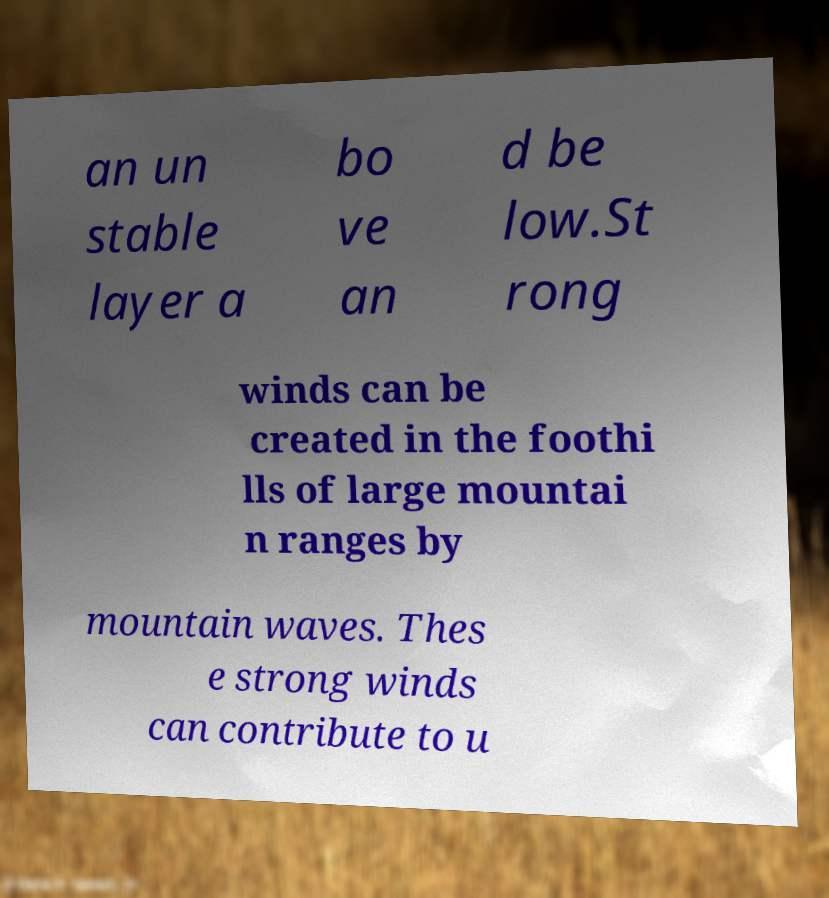Can you read and provide the text displayed in the image?This photo seems to have some interesting text. Can you extract and type it out for me? an un stable layer a bo ve an d be low.St rong winds can be created in the foothi lls of large mountai n ranges by mountain waves. Thes e strong winds can contribute to u 